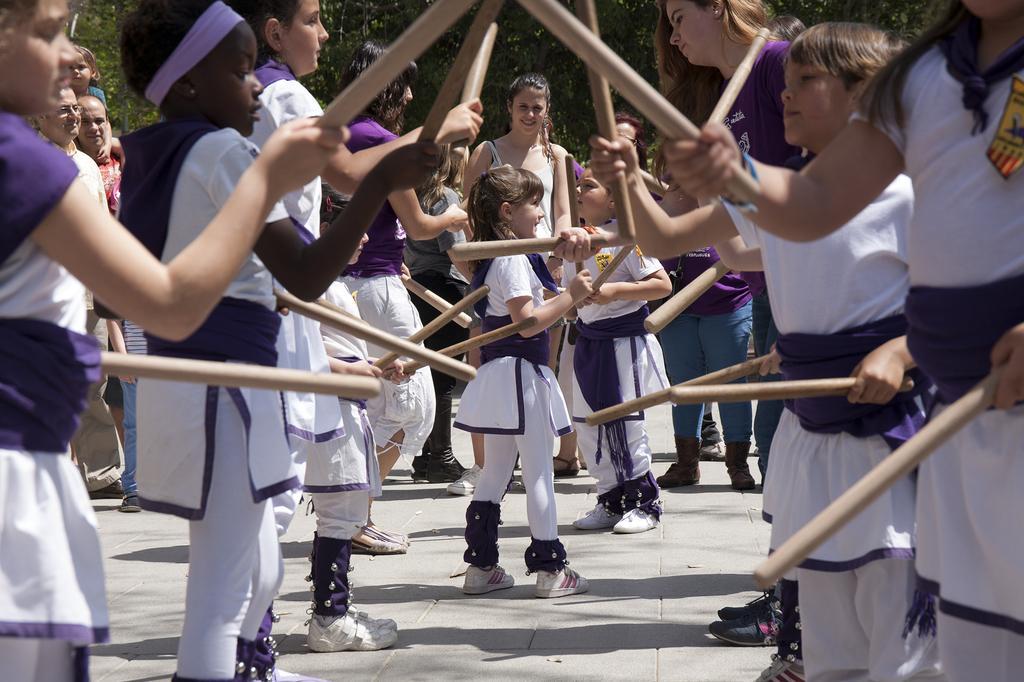Please provide a concise description of this image. In this image I can see the group of people standing on the road. These people are wearing the white and purple color dresses. These people are holding the wooden sticks. In the back there are few people with different color dresses. I can also see the trees in the back. 